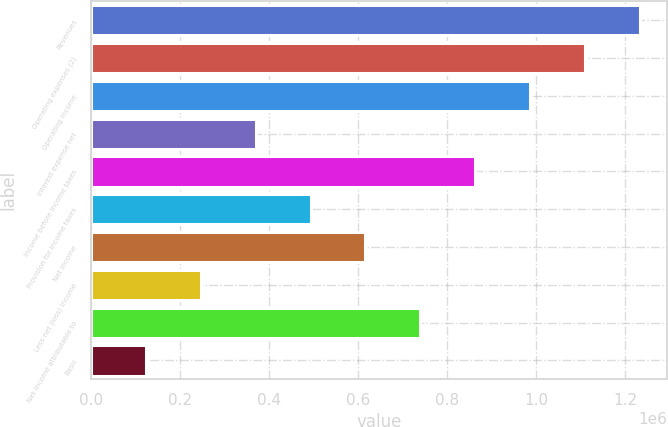Convert chart. <chart><loc_0><loc_0><loc_500><loc_500><bar_chart><fcel>Revenues<fcel>Operating expenses (2)<fcel>Operating income<fcel>Interest expense net<fcel>Income before income taxes<fcel>Provision for income taxes<fcel>Net income<fcel>Less net (loss) income<fcel>Net income attributable to<fcel>Basic<nl><fcel>1.2329e+06<fcel>1.10961e+06<fcel>986320<fcel>369871<fcel>863031<fcel>493161<fcel>616451<fcel>246582<fcel>739741<fcel>123292<nl></chart> 